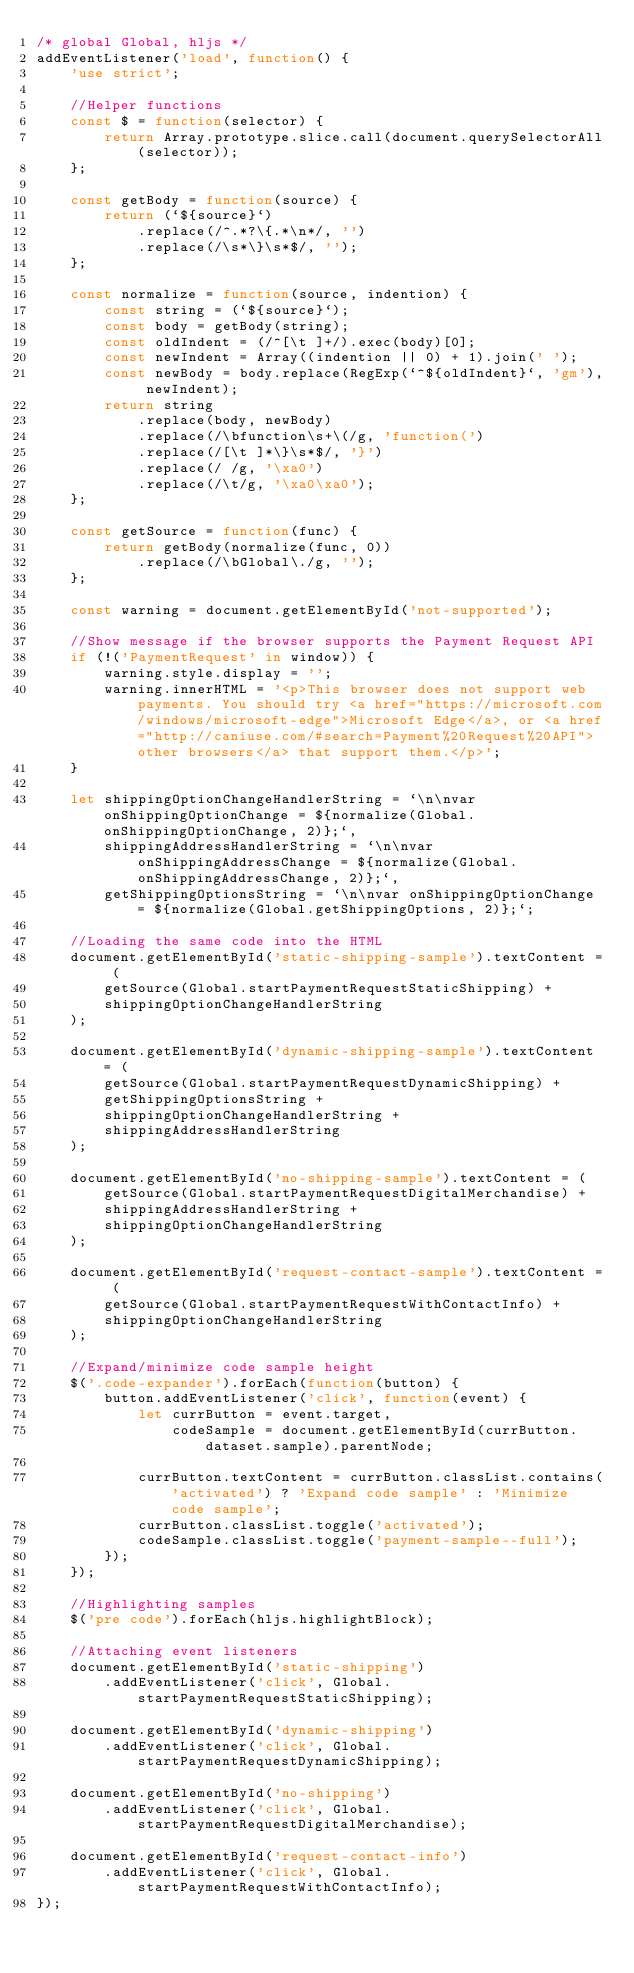<code> <loc_0><loc_0><loc_500><loc_500><_JavaScript_>/* global Global, hljs */
addEventListener('load', function() {
	'use strict';

	//Helper functions
	const $ = function(selector) {
		return Array.prototype.slice.call(document.querySelectorAll(selector));
	};

	const getBody = function(source) {
		return (`${source}`)
			.replace(/^.*?\{.*\n*/, '')
			.replace(/\s*\}\s*$/, '');
	};

	const normalize = function(source, indention) {
		const string = (`${source}`);
		const body = getBody(string);
		const oldIndent = (/^[\t ]+/).exec(body)[0];
		const newIndent = Array((indention || 0) + 1).join(' ');
		const newBody = body.replace(RegExp(`^${oldIndent}`, 'gm'), newIndent);
		return string
			.replace(body, newBody)
			.replace(/\bfunction\s+\(/g, 'function(')
			.replace(/[\t ]*\}\s*$/, '}')
			.replace(/ /g, '\xa0')
			.replace(/\t/g, '\xa0\xa0');
	};

	const getSource = function(func) {
		return getBody(normalize(func, 0))
			.replace(/\bGlobal\./g, '');
	};

	const warning = document.getElementById('not-supported');

	//Show message if the browser supports the Payment Request API
	if (!('PaymentRequest' in window)) {
		warning.style.display = '';
		warning.innerHTML = '<p>This browser does not support web payments. You should try <a href="https://microsoft.com/windows/microsoft-edge">Microsoft Edge</a>, or <a href="http://caniuse.com/#search=Payment%20Request%20API">other browsers</a> that support them.</p>';
	}

	let shippingOptionChangeHandlerString = `\n\nvar onShippingOptionChange = ${normalize(Global.onShippingOptionChange, 2)};`,
		shippingAddressHandlerString = `\n\nvar onShippingAddressChange = ${normalize(Global.onShippingAddressChange, 2)};`,
		getShippingOptionsString = `\n\nvar onShippingOptionChange = ${normalize(Global.getShippingOptions, 2)};`;

	//Loading the same code into the HTML
	document.getElementById('static-shipping-sample').textContent = (
		getSource(Global.startPaymentRequestStaticShipping) +
		shippingOptionChangeHandlerString
	);

	document.getElementById('dynamic-shipping-sample').textContent = (
		getSource(Global.startPaymentRequestDynamicShipping) +
		getShippingOptionsString +
		shippingOptionChangeHandlerString +
		shippingAddressHandlerString
	);

	document.getElementById('no-shipping-sample').textContent = (
		getSource(Global.startPaymentRequestDigitalMerchandise) +
		shippingAddressHandlerString +
		shippingOptionChangeHandlerString
	);

	document.getElementById('request-contact-sample').textContent = (
		getSource(Global.startPaymentRequestWithContactInfo) +
		shippingOptionChangeHandlerString
	);

	//Expand/minimize code sample height
	$('.code-expander').forEach(function(button) {
		button.addEventListener('click', function(event) {
			let currButton = event.target,
				codeSample = document.getElementById(currButton.dataset.sample).parentNode;

			currButton.textContent = currButton.classList.contains('activated') ? 'Expand code sample' : 'Minimize code sample';
			currButton.classList.toggle('activated');
			codeSample.classList.toggle('payment-sample--full');
		});
	});

	//Highlighting samples
	$('pre code').forEach(hljs.highlightBlock);

	//Attaching event listeners
	document.getElementById('static-shipping')
		.addEventListener('click', Global.startPaymentRequestStaticShipping);

	document.getElementById('dynamic-shipping')
		.addEventListener('click', Global.startPaymentRequestDynamicShipping);

	document.getElementById('no-shipping')
		.addEventListener('click', Global.startPaymentRequestDigitalMerchandise);

	document.getElementById('request-contact-info')
		.addEventListener('click', Global.startPaymentRequestWithContactInfo);
});
</code> 